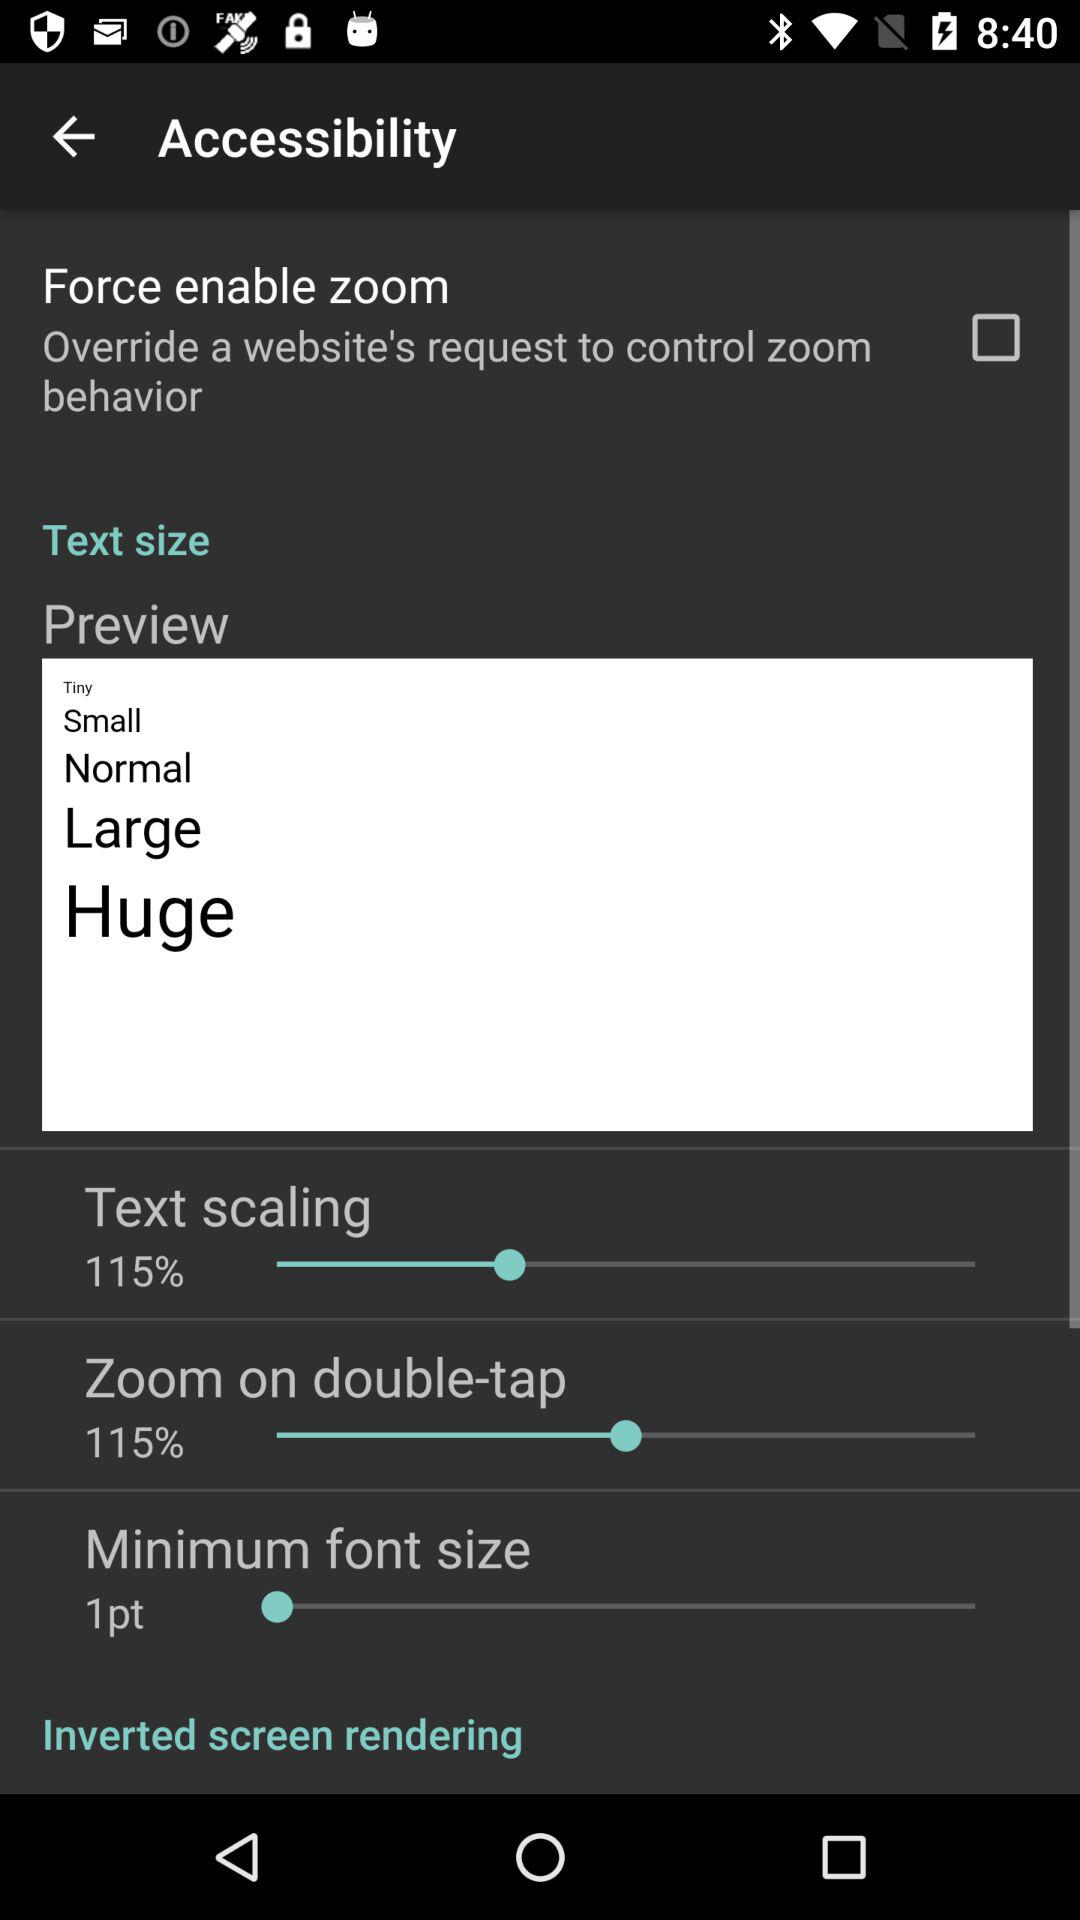What is the name of the application?
When the provided information is insufficient, respond with <no answer>. <no answer> 